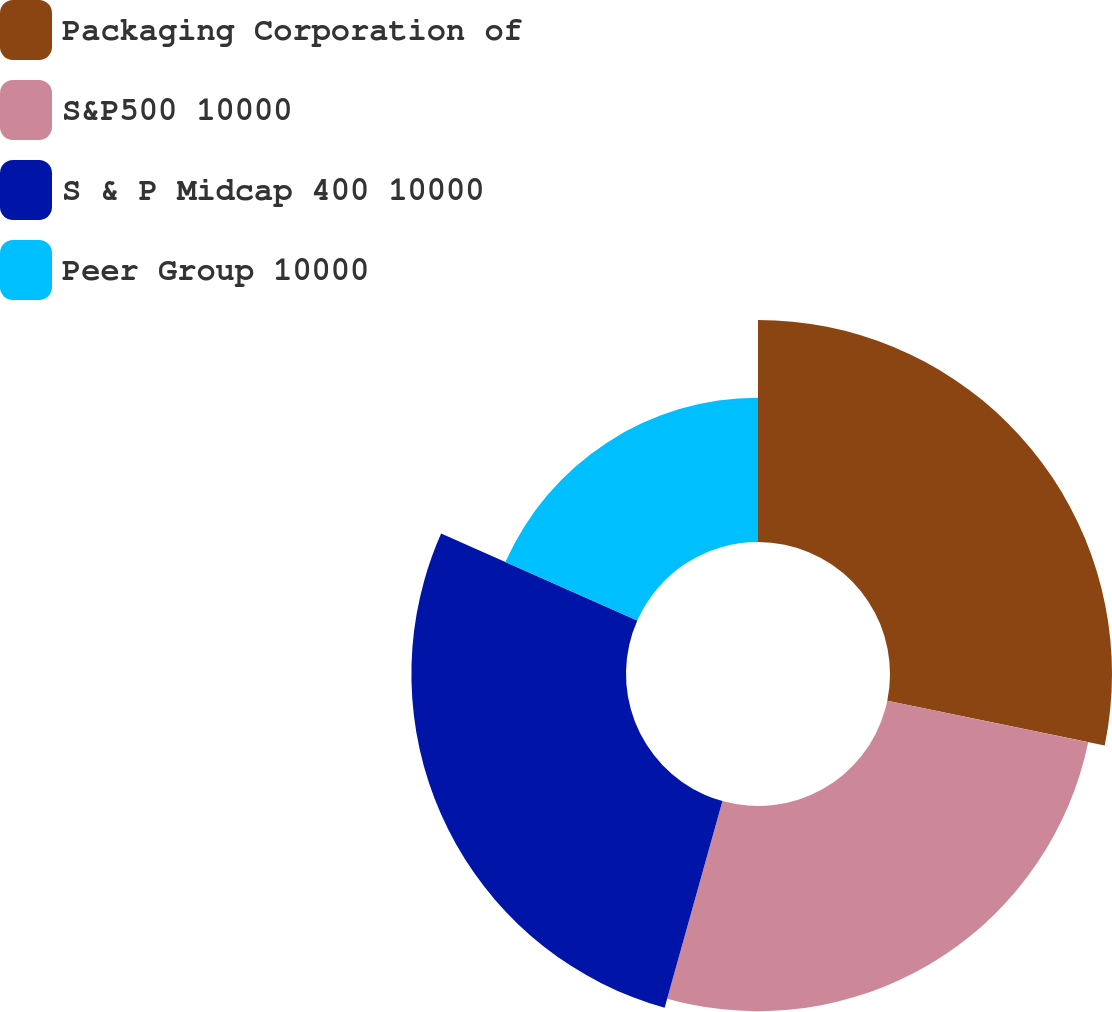Convert chart. <chart><loc_0><loc_0><loc_500><loc_500><pie_chart><fcel>Packaging Corporation of<fcel>S&P500 10000<fcel>S & P Midcap 400 10000<fcel>Peer Group 10000<nl><fcel>28.24%<fcel>26.1%<fcel>27.3%<fcel>18.36%<nl></chart> 